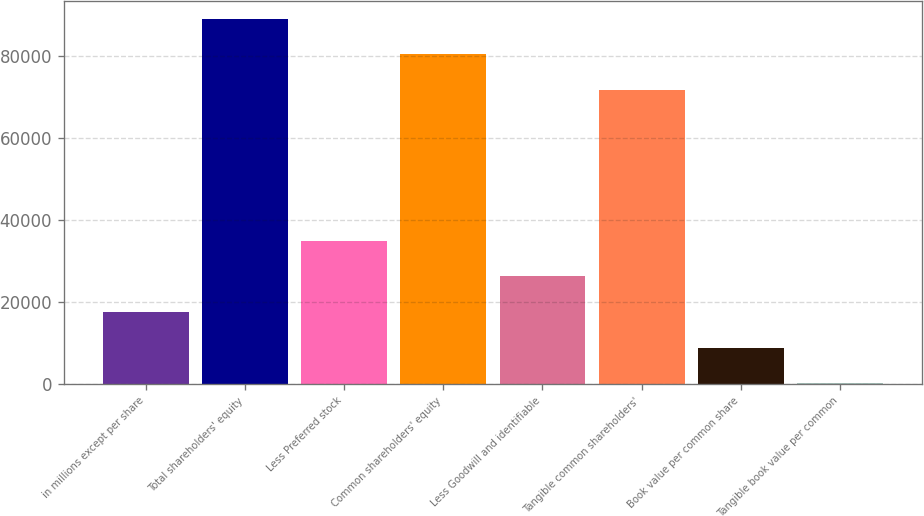Convert chart. <chart><loc_0><loc_0><loc_500><loc_500><bar_chart><fcel>in millions except per share<fcel>Total shareholders' equity<fcel>Less Preferred stock<fcel>Common shareholders' equity<fcel>Less Goodwill and identifiable<fcel>Tangible common shareholders'<fcel>Book value per common share<fcel>Tangible book value per common<nl><fcel>17516.7<fcel>88939.1<fcel>34860.8<fcel>80267<fcel>26188.7<fcel>71595<fcel>8844.64<fcel>172.6<nl></chart> 